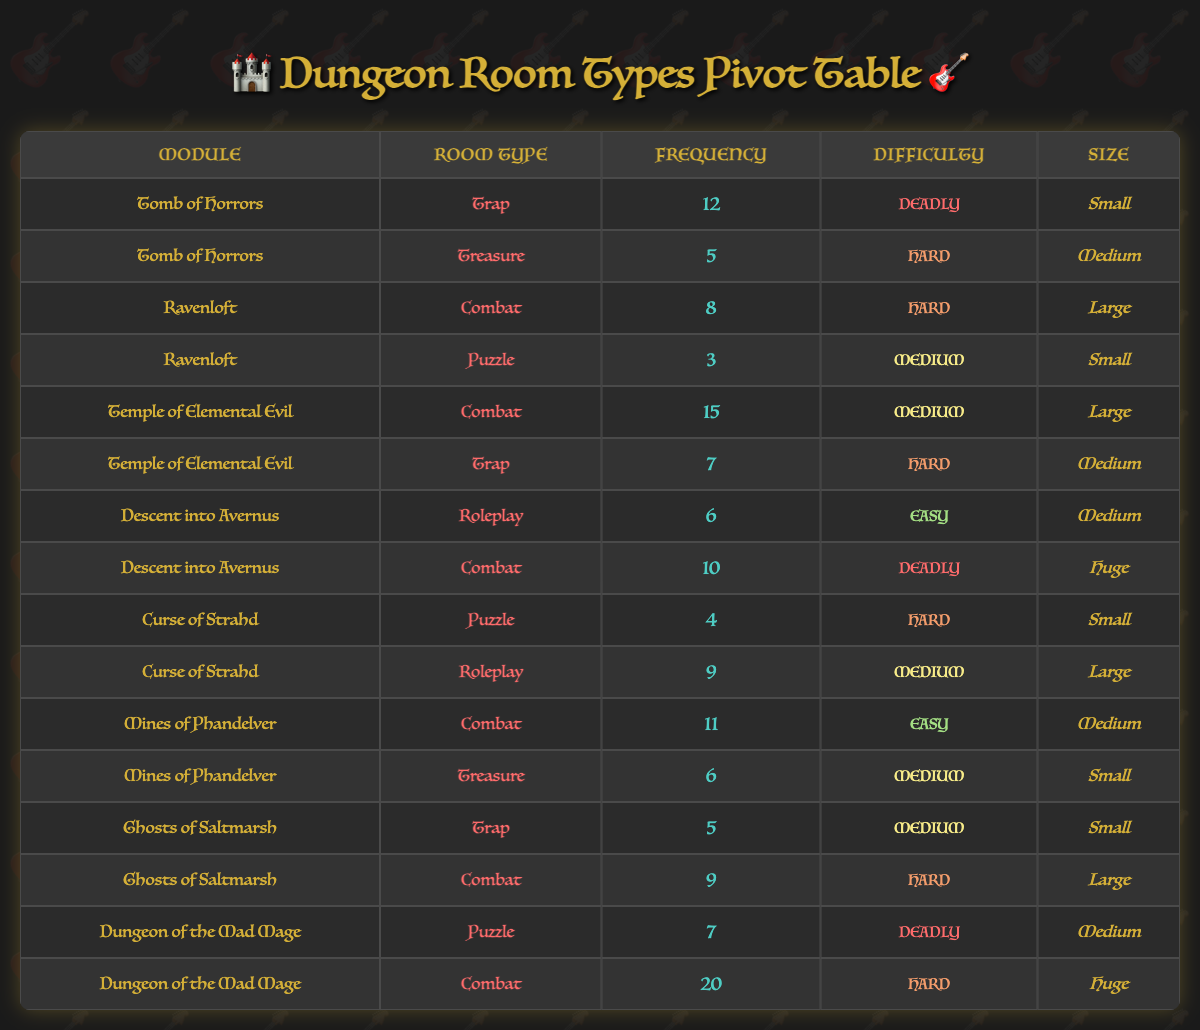What module has the highest frequency of Trap rooms? Looking at the "Frequency" column, the highest frequency for Trap rooms is 12, which is found in the "Tomb of Horrors" row.
Answer: Tomb of Horrors How many Combat rooms are there in total across all modules? Summing the frequencies of all rows listed as Combat: 8 (Ravenloft) + 15 (Temple of Elemental Evil) + 11 (Mines of Phandelver) + 10 (Descent into Avernus) + 20 (Dungeon of the Mad Mage) + 9 (Ghosts of Saltmarsh) = 73.
Answer: 73 Is there any Trap room that has a difficulty rated as Easy? Reviewing the table, all Trap rooms listed are either Deadly or Hard, and there are no Trap rooms with Easy difficulty.
Answer: No What is the average frequency of Puzzle rooms? The frequencies for Puzzle rooms are 3 (Ravenloft), 4 (Curse of Strahd), and 7 (Dungeon of the Mad Mage). Summing these gives 3 + 4 + 7 = 14; dividing by 3 (the number of Puzzle rooms) gives an average of 14 / 3 ≈ 4.67.
Answer: 4.67 Which module has the largest number of rooms overall? Evaluating each module: Tomb of Horrors has 2 rooms, Ravenloft has 2, Temple of Elemental Evil has 2, Descent into Avernus has 2, Curse of Strahd has 2, Mines of Phandelver has 2, Ghosts of Saltmarsh has 2, and Dungeon of the Mad Mage has 2. All modules have the same count, totaling 2 rooms each.
Answer: None Are there any Medium-sized rooms with Deadly difficulty? From the table, the only Medium-sized room listed with Deadly difficulty is the Trap from "Tomb of Horrors."
Answer: Yes What is the total frequency of Treasure rooms in all modules? The frequencies of Treasure rooms are 5 (Tomb of Horrors) and 6 (Mines of Phandelver) giving a total frequency of 5 + 6 = 11.
Answer: 11 Which type of room has the most occurrences overall? Analyzing the table, Trap rooms have a frequency of 12 (Tomb of Horrors), Combat rooms have 73, Puzzle rooms have 14, and Roleplay rooms have 15. Combat rooms have the highest frequency overall with 73 occurrences.
Answer: Combat rooms What is the most frequent difficulty level across all room types? The frequencies of each difficulty level are: Easy - 3, Medium - 23, Hard - 28, Deadly - 5. The most frequent difficulty level is Hard with 28 occurrences.
Answer: Hard 